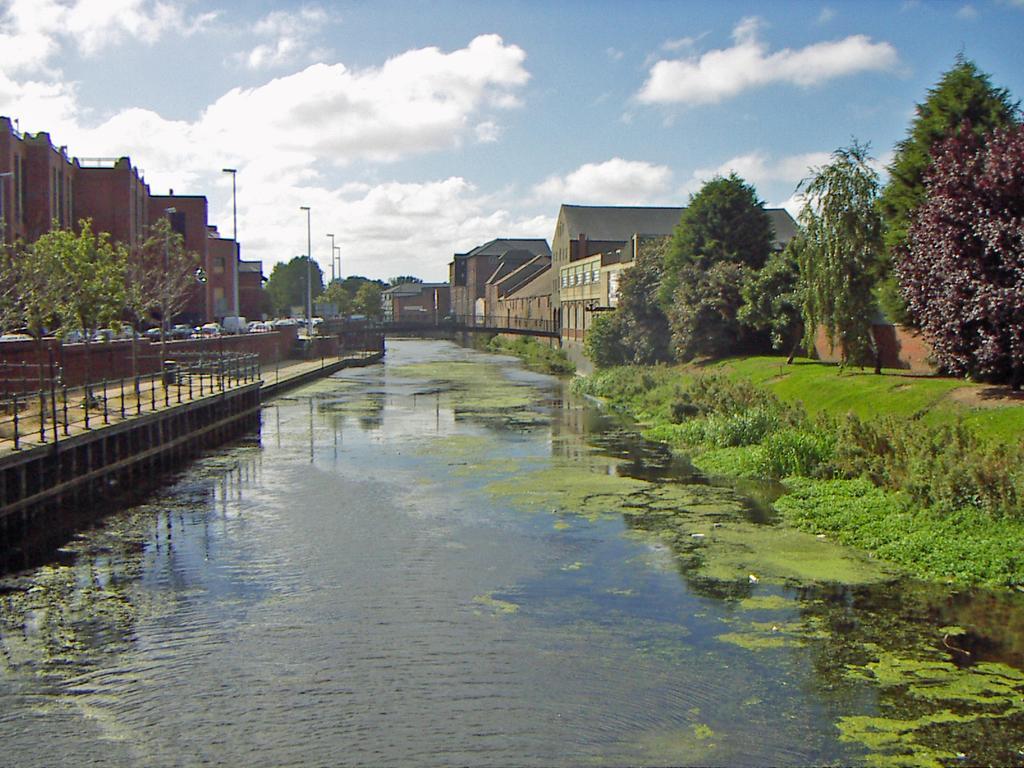Please provide a concise description of this image. In this image, there are a few buildings, poles, vehicles, trees, plants. We can also see some water. We can also see the fence and a bridge above the water. We can also see some grass and the sky with clouds. We can see some reflection in the water. 